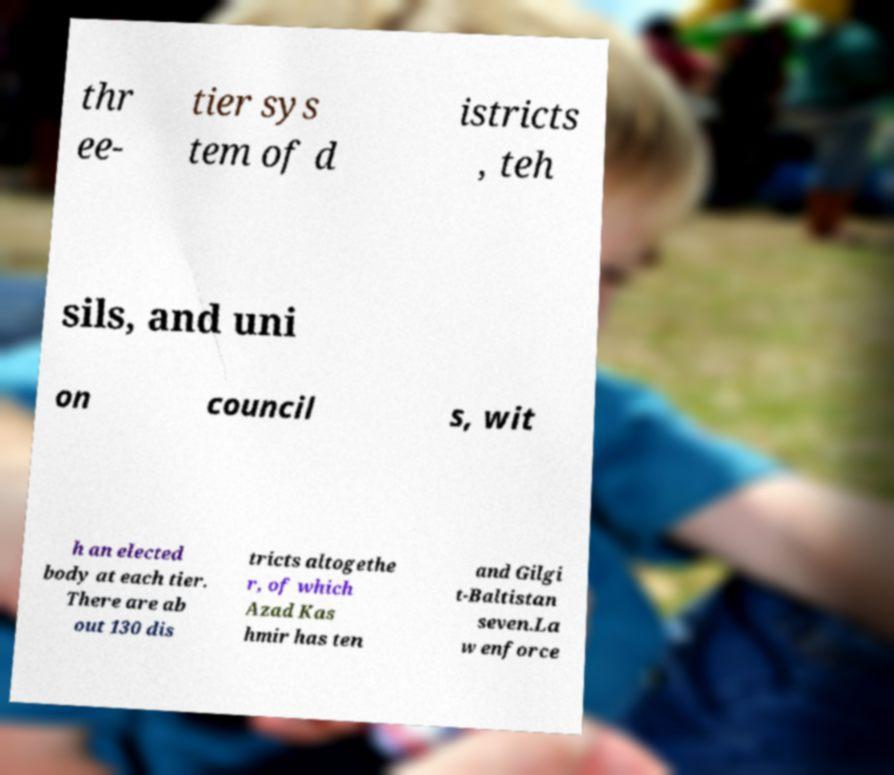What messages or text are displayed in this image? I need them in a readable, typed format. thr ee- tier sys tem of d istricts , teh sils, and uni on council s, wit h an elected body at each tier. There are ab out 130 dis tricts altogethe r, of which Azad Kas hmir has ten and Gilgi t-Baltistan seven.La w enforce 